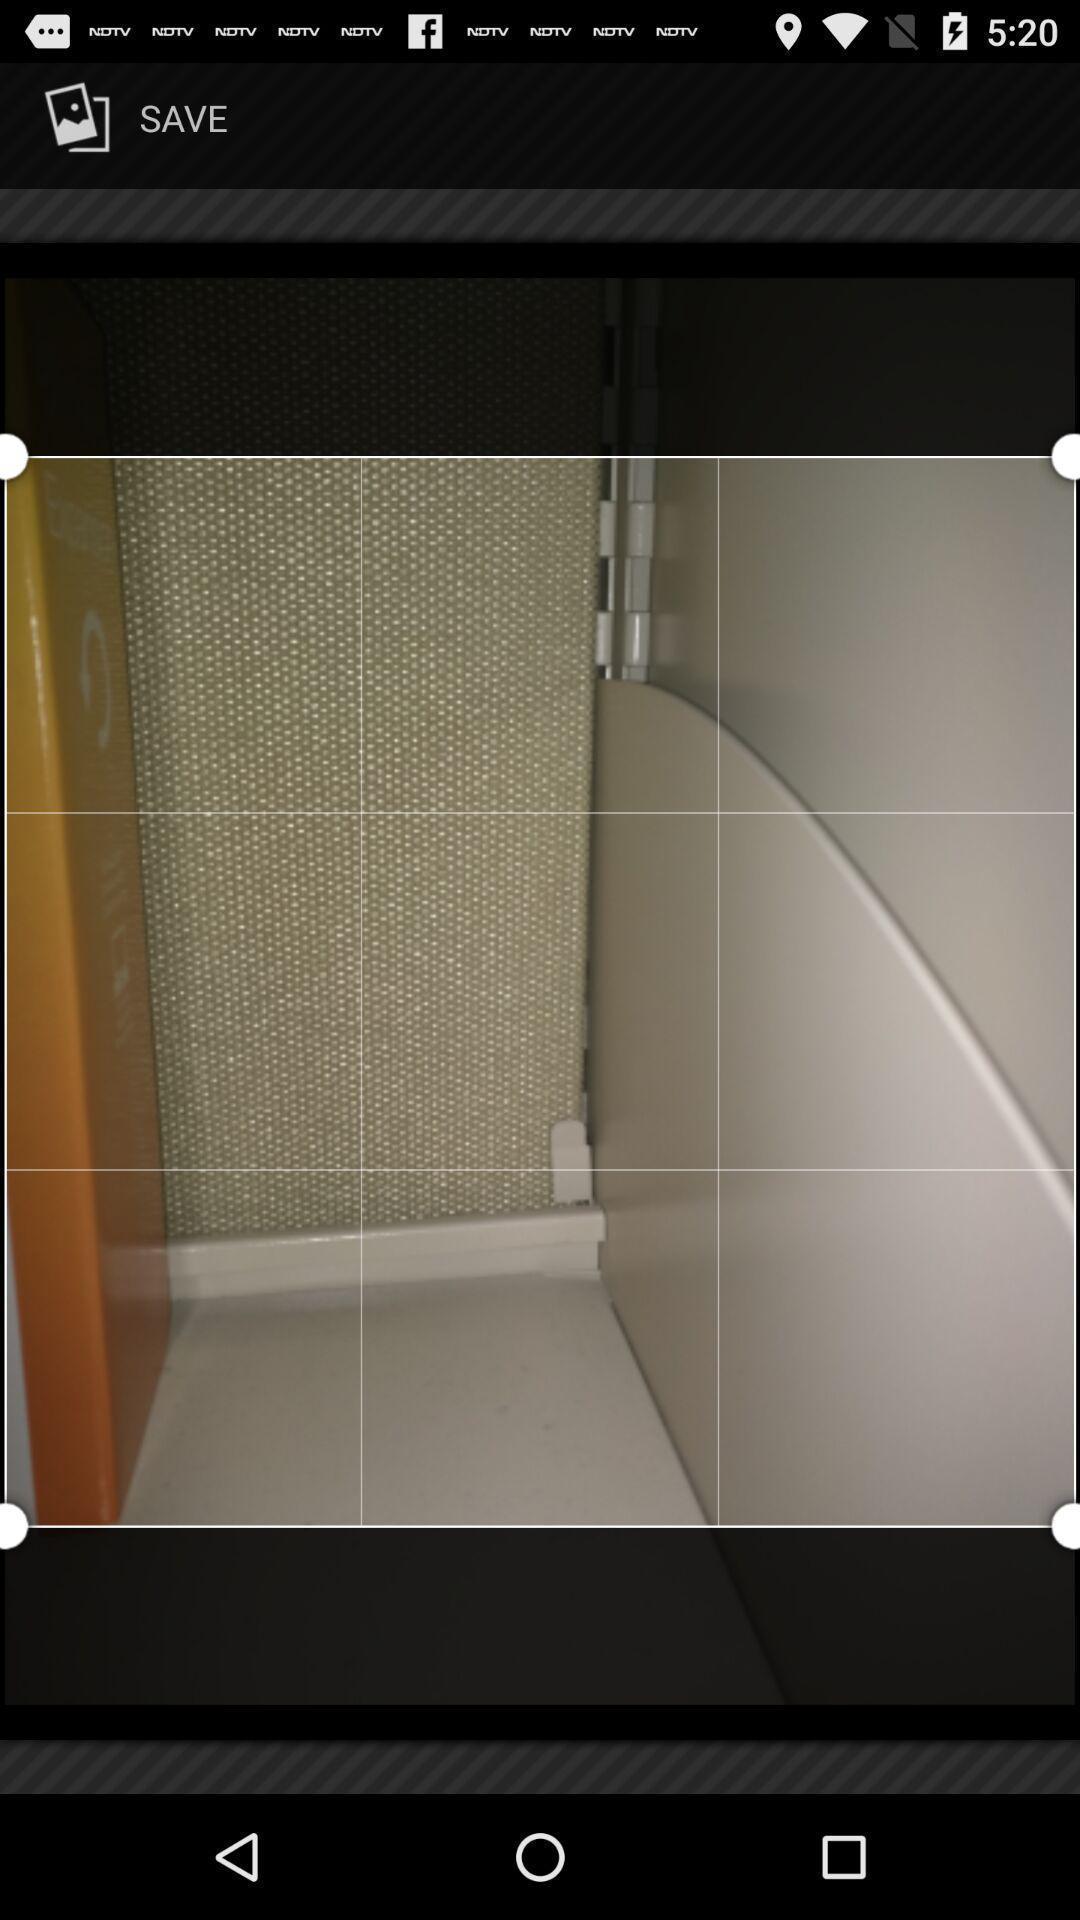Tell me what you see in this picture. Screen shows an image on a gallery. 